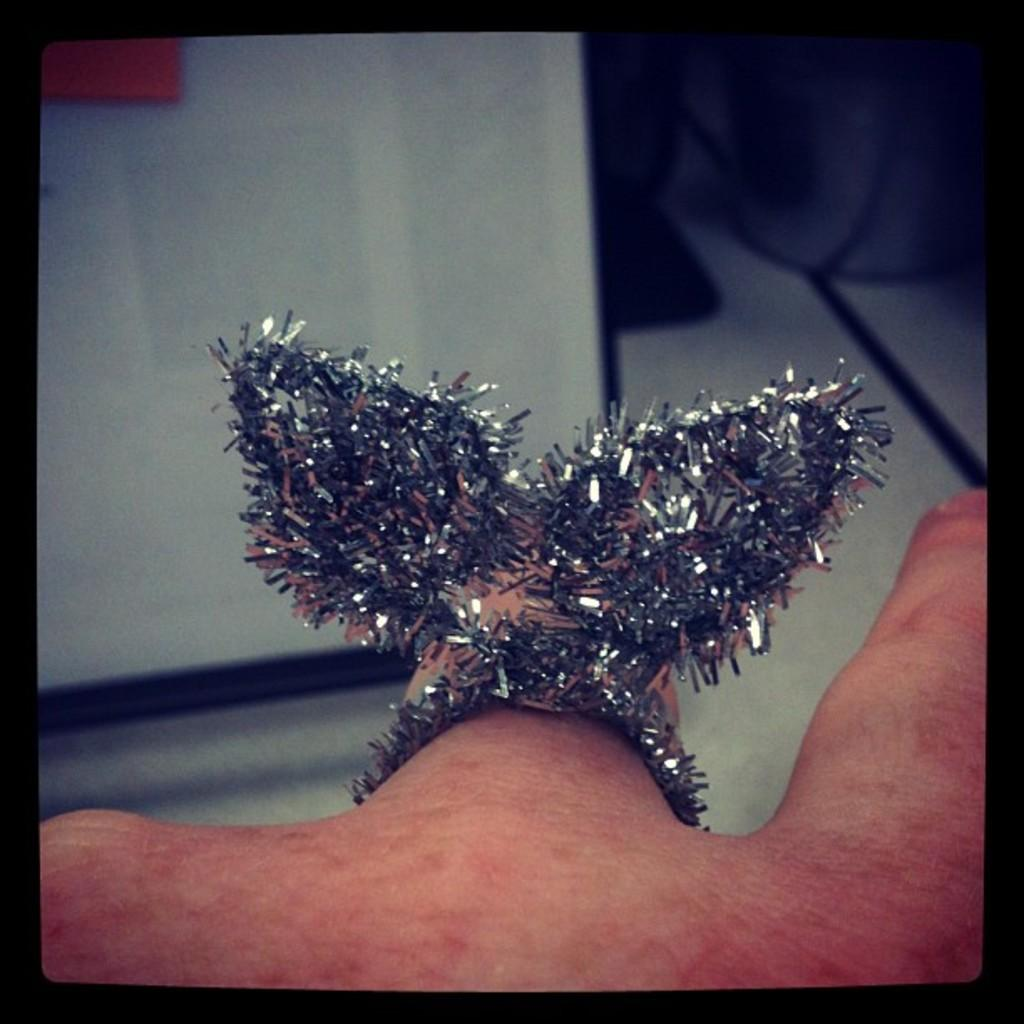Where was the image taken? The image was taken indoors. What can be seen at the top of the image? There is a table at the top of the image. What is visible at the bottom of the image? There is a hand with a finger ring at the bottom of the image. What type of drug is being used by the visitor in the image? There is no visitor or drug present in the image. What kind of ball is being played with in the image? There is no ball present in the image. 